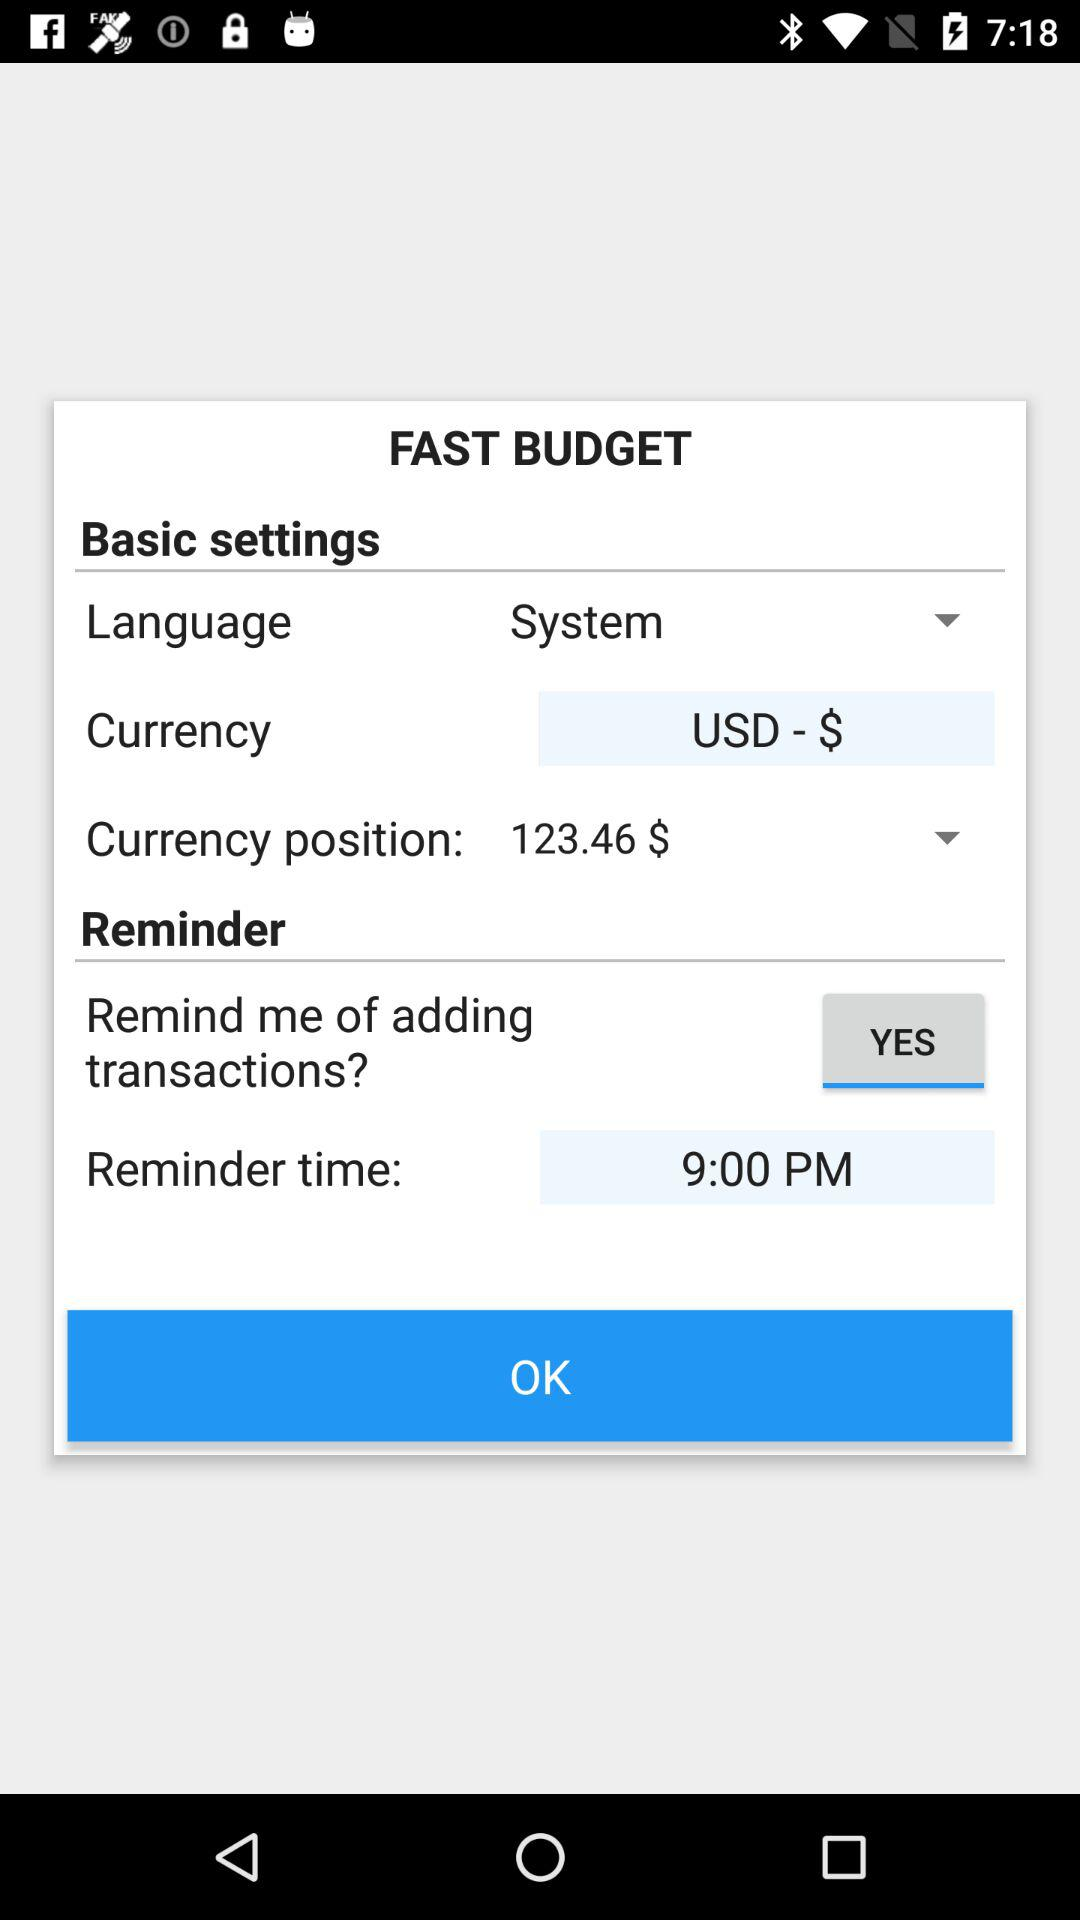What is the currency shown on the screen? The currency shown on the screen is USD ($). 